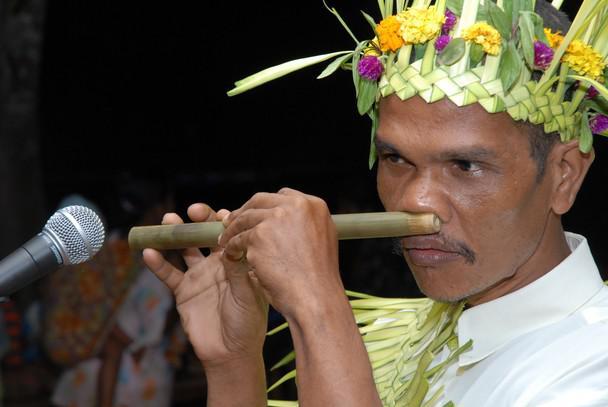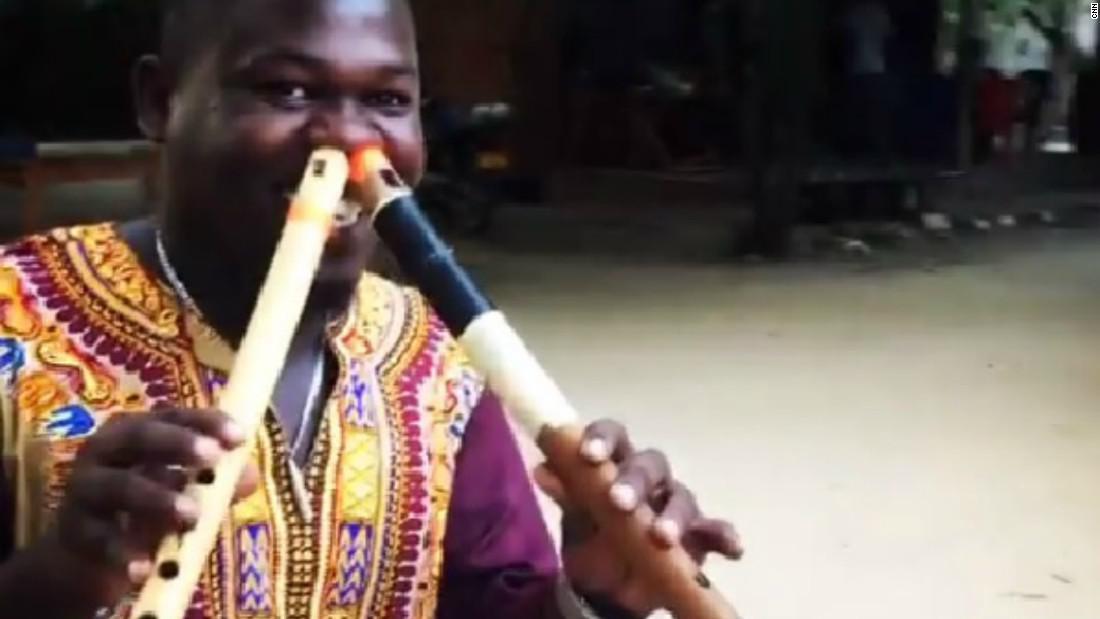The first image is the image on the left, the second image is the image on the right. Examine the images to the left and right. Is the description "Each image shows a man holding at least one flute to a nostril, but only the left image features a man in a red turban and bushy dark facial hair holding two flutes to his nostrils." accurate? Answer yes or no. No. The first image is the image on the left, the second image is the image on the right. For the images shown, is this caption "There is a man playing two nose flutes in each image" true? Answer yes or no. No. 